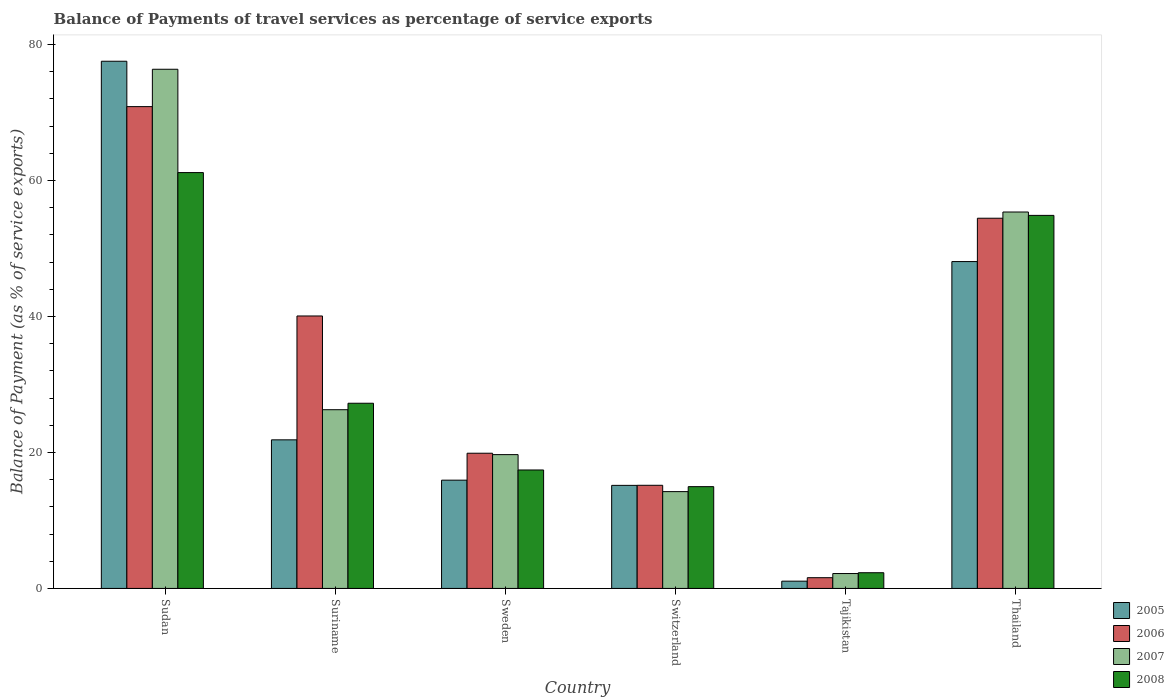Are the number of bars per tick equal to the number of legend labels?
Offer a very short reply. Yes. How many bars are there on the 1st tick from the left?
Your answer should be very brief. 4. What is the label of the 2nd group of bars from the left?
Offer a terse response. Suriname. What is the balance of payments of travel services in 2005 in Thailand?
Offer a very short reply. 48.07. Across all countries, what is the maximum balance of payments of travel services in 2006?
Offer a terse response. 70.85. Across all countries, what is the minimum balance of payments of travel services in 2007?
Provide a succinct answer. 2.19. In which country was the balance of payments of travel services in 2006 maximum?
Make the answer very short. Sudan. In which country was the balance of payments of travel services in 2006 minimum?
Your answer should be compact. Tajikistan. What is the total balance of payments of travel services in 2007 in the graph?
Your answer should be very brief. 194.09. What is the difference between the balance of payments of travel services in 2007 in Switzerland and that in Tajikistan?
Offer a very short reply. 12.05. What is the difference between the balance of payments of travel services in 2006 in Thailand and the balance of payments of travel services in 2008 in Sweden?
Your answer should be very brief. 37.02. What is the average balance of payments of travel services in 2006 per country?
Give a very brief answer. 33.67. What is the difference between the balance of payments of travel services of/in 2008 and balance of payments of travel services of/in 2007 in Sweden?
Your answer should be very brief. -2.26. What is the ratio of the balance of payments of travel services in 2008 in Sudan to that in Switzerland?
Ensure brevity in your answer.  4.09. Is the balance of payments of travel services in 2008 in Sweden less than that in Thailand?
Make the answer very short. Yes. Is the difference between the balance of payments of travel services in 2008 in Sweden and Tajikistan greater than the difference between the balance of payments of travel services in 2007 in Sweden and Tajikistan?
Your answer should be very brief. No. What is the difference between the highest and the second highest balance of payments of travel services in 2006?
Provide a short and direct response. 14.37. What is the difference between the highest and the lowest balance of payments of travel services in 2007?
Make the answer very short. 74.16. In how many countries, is the balance of payments of travel services in 2005 greater than the average balance of payments of travel services in 2005 taken over all countries?
Your response must be concise. 2. Is it the case that in every country, the sum of the balance of payments of travel services in 2007 and balance of payments of travel services in 2005 is greater than the sum of balance of payments of travel services in 2008 and balance of payments of travel services in 2006?
Ensure brevity in your answer.  No. What does the 1st bar from the right in Tajikistan represents?
Provide a short and direct response. 2008. How many bars are there?
Ensure brevity in your answer.  24. How many countries are there in the graph?
Keep it short and to the point. 6. What is the difference between two consecutive major ticks on the Y-axis?
Your answer should be very brief. 20. Does the graph contain grids?
Offer a terse response. No. How many legend labels are there?
Your answer should be compact. 4. What is the title of the graph?
Your answer should be compact. Balance of Payments of travel services as percentage of service exports. Does "1999" appear as one of the legend labels in the graph?
Provide a succinct answer. No. What is the label or title of the X-axis?
Make the answer very short. Country. What is the label or title of the Y-axis?
Provide a short and direct response. Balance of Payment (as % of service exports). What is the Balance of Payment (as % of service exports) of 2005 in Sudan?
Your answer should be very brief. 77.53. What is the Balance of Payment (as % of service exports) in 2006 in Sudan?
Make the answer very short. 70.85. What is the Balance of Payment (as % of service exports) of 2007 in Sudan?
Your answer should be very brief. 76.35. What is the Balance of Payment (as % of service exports) of 2008 in Sudan?
Your answer should be very brief. 61.15. What is the Balance of Payment (as % of service exports) in 2005 in Suriname?
Ensure brevity in your answer.  21.85. What is the Balance of Payment (as % of service exports) of 2006 in Suriname?
Give a very brief answer. 40.07. What is the Balance of Payment (as % of service exports) in 2007 in Suriname?
Keep it short and to the point. 26.28. What is the Balance of Payment (as % of service exports) in 2008 in Suriname?
Provide a short and direct response. 27.23. What is the Balance of Payment (as % of service exports) of 2005 in Sweden?
Provide a short and direct response. 15.92. What is the Balance of Payment (as % of service exports) in 2006 in Sweden?
Keep it short and to the point. 19.88. What is the Balance of Payment (as % of service exports) in 2007 in Sweden?
Your answer should be very brief. 19.68. What is the Balance of Payment (as % of service exports) in 2008 in Sweden?
Your answer should be very brief. 17.42. What is the Balance of Payment (as % of service exports) of 2005 in Switzerland?
Provide a succinct answer. 15.16. What is the Balance of Payment (as % of service exports) in 2006 in Switzerland?
Offer a terse response. 15.17. What is the Balance of Payment (as % of service exports) in 2007 in Switzerland?
Ensure brevity in your answer.  14.24. What is the Balance of Payment (as % of service exports) of 2008 in Switzerland?
Offer a terse response. 14.97. What is the Balance of Payment (as % of service exports) in 2005 in Tajikistan?
Keep it short and to the point. 1.07. What is the Balance of Payment (as % of service exports) in 2006 in Tajikistan?
Keep it short and to the point. 1.58. What is the Balance of Payment (as % of service exports) of 2007 in Tajikistan?
Your response must be concise. 2.19. What is the Balance of Payment (as % of service exports) of 2008 in Tajikistan?
Ensure brevity in your answer.  2.31. What is the Balance of Payment (as % of service exports) in 2005 in Thailand?
Offer a terse response. 48.07. What is the Balance of Payment (as % of service exports) of 2006 in Thailand?
Provide a short and direct response. 54.44. What is the Balance of Payment (as % of service exports) in 2007 in Thailand?
Provide a short and direct response. 55.36. What is the Balance of Payment (as % of service exports) in 2008 in Thailand?
Offer a very short reply. 54.86. Across all countries, what is the maximum Balance of Payment (as % of service exports) in 2005?
Give a very brief answer. 77.53. Across all countries, what is the maximum Balance of Payment (as % of service exports) of 2006?
Your response must be concise. 70.85. Across all countries, what is the maximum Balance of Payment (as % of service exports) of 2007?
Ensure brevity in your answer.  76.35. Across all countries, what is the maximum Balance of Payment (as % of service exports) of 2008?
Keep it short and to the point. 61.15. Across all countries, what is the minimum Balance of Payment (as % of service exports) of 2005?
Provide a succinct answer. 1.07. Across all countries, what is the minimum Balance of Payment (as % of service exports) of 2006?
Provide a succinct answer. 1.58. Across all countries, what is the minimum Balance of Payment (as % of service exports) of 2007?
Your answer should be very brief. 2.19. Across all countries, what is the minimum Balance of Payment (as % of service exports) in 2008?
Offer a terse response. 2.31. What is the total Balance of Payment (as % of service exports) of 2005 in the graph?
Provide a short and direct response. 179.6. What is the total Balance of Payment (as % of service exports) in 2006 in the graph?
Make the answer very short. 201.99. What is the total Balance of Payment (as % of service exports) in 2007 in the graph?
Make the answer very short. 194.09. What is the total Balance of Payment (as % of service exports) of 2008 in the graph?
Give a very brief answer. 177.95. What is the difference between the Balance of Payment (as % of service exports) of 2005 in Sudan and that in Suriname?
Provide a short and direct response. 55.68. What is the difference between the Balance of Payment (as % of service exports) of 2006 in Sudan and that in Suriname?
Ensure brevity in your answer.  30.79. What is the difference between the Balance of Payment (as % of service exports) of 2007 in Sudan and that in Suriname?
Provide a succinct answer. 50.07. What is the difference between the Balance of Payment (as % of service exports) in 2008 in Sudan and that in Suriname?
Your answer should be very brief. 33.92. What is the difference between the Balance of Payment (as % of service exports) in 2005 in Sudan and that in Sweden?
Your answer should be very brief. 61.61. What is the difference between the Balance of Payment (as % of service exports) in 2006 in Sudan and that in Sweden?
Your response must be concise. 50.97. What is the difference between the Balance of Payment (as % of service exports) of 2007 in Sudan and that in Sweden?
Offer a terse response. 56.67. What is the difference between the Balance of Payment (as % of service exports) in 2008 in Sudan and that in Sweden?
Keep it short and to the point. 43.73. What is the difference between the Balance of Payment (as % of service exports) of 2005 in Sudan and that in Switzerland?
Offer a very short reply. 62.37. What is the difference between the Balance of Payment (as % of service exports) in 2006 in Sudan and that in Switzerland?
Offer a very short reply. 55.69. What is the difference between the Balance of Payment (as % of service exports) of 2007 in Sudan and that in Switzerland?
Ensure brevity in your answer.  62.11. What is the difference between the Balance of Payment (as % of service exports) in 2008 in Sudan and that in Switzerland?
Make the answer very short. 46.19. What is the difference between the Balance of Payment (as % of service exports) in 2005 in Sudan and that in Tajikistan?
Your answer should be compact. 76.46. What is the difference between the Balance of Payment (as % of service exports) in 2006 in Sudan and that in Tajikistan?
Provide a short and direct response. 69.28. What is the difference between the Balance of Payment (as % of service exports) in 2007 in Sudan and that in Tajikistan?
Your response must be concise. 74.16. What is the difference between the Balance of Payment (as % of service exports) of 2008 in Sudan and that in Tajikistan?
Your response must be concise. 58.84. What is the difference between the Balance of Payment (as % of service exports) of 2005 in Sudan and that in Thailand?
Ensure brevity in your answer.  29.46. What is the difference between the Balance of Payment (as % of service exports) of 2006 in Sudan and that in Thailand?
Provide a short and direct response. 16.41. What is the difference between the Balance of Payment (as % of service exports) in 2007 in Sudan and that in Thailand?
Your response must be concise. 20.99. What is the difference between the Balance of Payment (as % of service exports) of 2008 in Sudan and that in Thailand?
Provide a short and direct response. 6.29. What is the difference between the Balance of Payment (as % of service exports) of 2005 in Suriname and that in Sweden?
Your response must be concise. 5.93. What is the difference between the Balance of Payment (as % of service exports) in 2006 in Suriname and that in Sweden?
Give a very brief answer. 20.18. What is the difference between the Balance of Payment (as % of service exports) in 2007 in Suriname and that in Sweden?
Give a very brief answer. 6.6. What is the difference between the Balance of Payment (as % of service exports) of 2008 in Suriname and that in Sweden?
Offer a terse response. 9.81. What is the difference between the Balance of Payment (as % of service exports) in 2005 in Suriname and that in Switzerland?
Your answer should be very brief. 6.7. What is the difference between the Balance of Payment (as % of service exports) in 2006 in Suriname and that in Switzerland?
Provide a short and direct response. 24.9. What is the difference between the Balance of Payment (as % of service exports) of 2007 in Suriname and that in Switzerland?
Ensure brevity in your answer.  12.04. What is the difference between the Balance of Payment (as % of service exports) of 2008 in Suriname and that in Switzerland?
Make the answer very short. 12.27. What is the difference between the Balance of Payment (as % of service exports) of 2005 in Suriname and that in Tajikistan?
Give a very brief answer. 20.78. What is the difference between the Balance of Payment (as % of service exports) of 2006 in Suriname and that in Tajikistan?
Your answer should be very brief. 38.49. What is the difference between the Balance of Payment (as % of service exports) in 2007 in Suriname and that in Tajikistan?
Offer a very short reply. 24.09. What is the difference between the Balance of Payment (as % of service exports) in 2008 in Suriname and that in Tajikistan?
Your answer should be compact. 24.92. What is the difference between the Balance of Payment (as % of service exports) of 2005 in Suriname and that in Thailand?
Ensure brevity in your answer.  -26.22. What is the difference between the Balance of Payment (as % of service exports) of 2006 in Suriname and that in Thailand?
Ensure brevity in your answer.  -14.37. What is the difference between the Balance of Payment (as % of service exports) in 2007 in Suriname and that in Thailand?
Ensure brevity in your answer.  -29.07. What is the difference between the Balance of Payment (as % of service exports) in 2008 in Suriname and that in Thailand?
Your answer should be very brief. -27.63. What is the difference between the Balance of Payment (as % of service exports) in 2005 in Sweden and that in Switzerland?
Your response must be concise. 0.77. What is the difference between the Balance of Payment (as % of service exports) in 2006 in Sweden and that in Switzerland?
Offer a very short reply. 4.72. What is the difference between the Balance of Payment (as % of service exports) in 2007 in Sweden and that in Switzerland?
Make the answer very short. 5.44. What is the difference between the Balance of Payment (as % of service exports) of 2008 in Sweden and that in Switzerland?
Provide a short and direct response. 2.45. What is the difference between the Balance of Payment (as % of service exports) of 2005 in Sweden and that in Tajikistan?
Give a very brief answer. 14.85. What is the difference between the Balance of Payment (as % of service exports) in 2006 in Sweden and that in Tajikistan?
Offer a terse response. 18.3. What is the difference between the Balance of Payment (as % of service exports) in 2007 in Sweden and that in Tajikistan?
Offer a very short reply. 17.49. What is the difference between the Balance of Payment (as % of service exports) in 2008 in Sweden and that in Tajikistan?
Your answer should be very brief. 15.11. What is the difference between the Balance of Payment (as % of service exports) in 2005 in Sweden and that in Thailand?
Your answer should be very brief. -32.15. What is the difference between the Balance of Payment (as % of service exports) of 2006 in Sweden and that in Thailand?
Provide a succinct answer. -34.56. What is the difference between the Balance of Payment (as % of service exports) in 2007 in Sweden and that in Thailand?
Your answer should be very brief. -35.68. What is the difference between the Balance of Payment (as % of service exports) of 2008 in Sweden and that in Thailand?
Your answer should be very brief. -37.44. What is the difference between the Balance of Payment (as % of service exports) of 2005 in Switzerland and that in Tajikistan?
Provide a succinct answer. 14.09. What is the difference between the Balance of Payment (as % of service exports) in 2006 in Switzerland and that in Tajikistan?
Ensure brevity in your answer.  13.59. What is the difference between the Balance of Payment (as % of service exports) in 2007 in Switzerland and that in Tajikistan?
Your response must be concise. 12.05. What is the difference between the Balance of Payment (as % of service exports) in 2008 in Switzerland and that in Tajikistan?
Ensure brevity in your answer.  12.66. What is the difference between the Balance of Payment (as % of service exports) in 2005 in Switzerland and that in Thailand?
Keep it short and to the point. -32.91. What is the difference between the Balance of Payment (as % of service exports) of 2006 in Switzerland and that in Thailand?
Give a very brief answer. -39.28. What is the difference between the Balance of Payment (as % of service exports) of 2007 in Switzerland and that in Thailand?
Make the answer very short. -41.12. What is the difference between the Balance of Payment (as % of service exports) in 2008 in Switzerland and that in Thailand?
Your response must be concise. -39.89. What is the difference between the Balance of Payment (as % of service exports) in 2005 in Tajikistan and that in Thailand?
Provide a short and direct response. -47. What is the difference between the Balance of Payment (as % of service exports) in 2006 in Tajikistan and that in Thailand?
Your answer should be compact. -52.86. What is the difference between the Balance of Payment (as % of service exports) of 2007 in Tajikistan and that in Thailand?
Offer a very short reply. -53.17. What is the difference between the Balance of Payment (as % of service exports) of 2008 in Tajikistan and that in Thailand?
Offer a terse response. -52.55. What is the difference between the Balance of Payment (as % of service exports) in 2005 in Sudan and the Balance of Payment (as % of service exports) in 2006 in Suriname?
Your answer should be very brief. 37.46. What is the difference between the Balance of Payment (as % of service exports) in 2005 in Sudan and the Balance of Payment (as % of service exports) in 2007 in Suriname?
Ensure brevity in your answer.  51.25. What is the difference between the Balance of Payment (as % of service exports) of 2005 in Sudan and the Balance of Payment (as % of service exports) of 2008 in Suriname?
Your answer should be compact. 50.29. What is the difference between the Balance of Payment (as % of service exports) of 2006 in Sudan and the Balance of Payment (as % of service exports) of 2007 in Suriname?
Provide a succinct answer. 44.57. What is the difference between the Balance of Payment (as % of service exports) of 2006 in Sudan and the Balance of Payment (as % of service exports) of 2008 in Suriname?
Provide a succinct answer. 43.62. What is the difference between the Balance of Payment (as % of service exports) in 2007 in Sudan and the Balance of Payment (as % of service exports) in 2008 in Suriname?
Your response must be concise. 49.12. What is the difference between the Balance of Payment (as % of service exports) of 2005 in Sudan and the Balance of Payment (as % of service exports) of 2006 in Sweden?
Give a very brief answer. 57.65. What is the difference between the Balance of Payment (as % of service exports) in 2005 in Sudan and the Balance of Payment (as % of service exports) in 2007 in Sweden?
Your answer should be compact. 57.85. What is the difference between the Balance of Payment (as % of service exports) of 2005 in Sudan and the Balance of Payment (as % of service exports) of 2008 in Sweden?
Provide a short and direct response. 60.11. What is the difference between the Balance of Payment (as % of service exports) of 2006 in Sudan and the Balance of Payment (as % of service exports) of 2007 in Sweden?
Offer a very short reply. 51.18. What is the difference between the Balance of Payment (as % of service exports) in 2006 in Sudan and the Balance of Payment (as % of service exports) in 2008 in Sweden?
Provide a succinct answer. 53.43. What is the difference between the Balance of Payment (as % of service exports) of 2007 in Sudan and the Balance of Payment (as % of service exports) of 2008 in Sweden?
Your answer should be compact. 58.93. What is the difference between the Balance of Payment (as % of service exports) in 2005 in Sudan and the Balance of Payment (as % of service exports) in 2006 in Switzerland?
Ensure brevity in your answer.  62.36. What is the difference between the Balance of Payment (as % of service exports) of 2005 in Sudan and the Balance of Payment (as % of service exports) of 2007 in Switzerland?
Offer a very short reply. 63.29. What is the difference between the Balance of Payment (as % of service exports) of 2005 in Sudan and the Balance of Payment (as % of service exports) of 2008 in Switzerland?
Offer a terse response. 62.56. What is the difference between the Balance of Payment (as % of service exports) in 2006 in Sudan and the Balance of Payment (as % of service exports) in 2007 in Switzerland?
Keep it short and to the point. 56.62. What is the difference between the Balance of Payment (as % of service exports) of 2006 in Sudan and the Balance of Payment (as % of service exports) of 2008 in Switzerland?
Provide a short and direct response. 55.89. What is the difference between the Balance of Payment (as % of service exports) in 2007 in Sudan and the Balance of Payment (as % of service exports) in 2008 in Switzerland?
Make the answer very short. 61.38. What is the difference between the Balance of Payment (as % of service exports) of 2005 in Sudan and the Balance of Payment (as % of service exports) of 2006 in Tajikistan?
Provide a succinct answer. 75.95. What is the difference between the Balance of Payment (as % of service exports) in 2005 in Sudan and the Balance of Payment (as % of service exports) in 2007 in Tajikistan?
Ensure brevity in your answer.  75.34. What is the difference between the Balance of Payment (as % of service exports) in 2005 in Sudan and the Balance of Payment (as % of service exports) in 2008 in Tajikistan?
Offer a very short reply. 75.22. What is the difference between the Balance of Payment (as % of service exports) in 2006 in Sudan and the Balance of Payment (as % of service exports) in 2007 in Tajikistan?
Make the answer very short. 68.66. What is the difference between the Balance of Payment (as % of service exports) of 2006 in Sudan and the Balance of Payment (as % of service exports) of 2008 in Tajikistan?
Offer a terse response. 68.54. What is the difference between the Balance of Payment (as % of service exports) in 2007 in Sudan and the Balance of Payment (as % of service exports) in 2008 in Tajikistan?
Offer a terse response. 74.04. What is the difference between the Balance of Payment (as % of service exports) of 2005 in Sudan and the Balance of Payment (as % of service exports) of 2006 in Thailand?
Offer a very short reply. 23.09. What is the difference between the Balance of Payment (as % of service exports) in 2005 in Sudan and the Balance of Payment (as % of service exports) in 2007 in Thailand?
Provide a short and direct response. 22.17. What is the difference between the Balance of Payment (as % of service exports) in 2005 in Sudan and the Balance of Payment (as % of service exports) in 2008 in Thailand?
Offer a very short reply. 22.67. What is the difference between the Balance of Payment (as % of service exports) of 2006 in Sudan and the Balance of Payment (as % of service exports) of 2007 in Thailand?
Ensure brevity in your answer.  15.5. What is the difference between the Balance of Payment (as % of service exports) of 2006 in Sudan and the Balance of Payment (as % of service exports) of 2008 in Thailand?
Provide a succinct answer. 15.99. What is the difference between the Balance of Payment (as % of service exports) of 2007 in Sudan and the Balance of Payment (as % of service exports) of 2008 in Thailand?
Your answer should be very brief. 21.49. What is the difference between the Balance of Payment (as % of service exports) in 2005 in Suriname and the Balance of Payment (as % of service exports) in 2006 in Sweden?
Your answer should be compact. 1.97. What is the difference between the Balance of Payment (as % of service exports) of 2005 in Suriname and the Balance of Payment (as % of service exports) of 2007 in Sweden?
Offer a terse response. 2.17. What is the difference between the Balance of Payment (as % of service exports) in 2005 in Suriname and the Balance of Payment (as % of service exports) in 2008 in Sweden?
Provide a short and direct response. 4.43. What is the difference between the Balance of Payment (as % of service exports) in 2006 in Suriname and the Balance of Payment (as % of service exports) in 2007 in Sweden?
Keep it short and to the point. 20.39. What is the difference between the Balance of Payment (as % of service exports) of 2006 in Suriname and the Balance of Payment (as % of service exports) of 2008 in Sweden?
Offer a very short reply. 22.65. What is the difference between the Balance of Payment (as % of service exports) in 2007 in Suriname and the Balance of Payment (as % of service exports) in 2008 in Sweden?
Make the answer very short. 8.86. What is the difference between the Balance of Payment (as % of service exports) in 2005 in Suriname and the Balance of Payment (as % of service exports) in 2006 in Switzerland?
Provide a succinct answer. 6.68. What is the difference between the Balance of Payment (as % of service exports) of 2005 in Suriname and the Balance of Payment (as % of service exports) of 2007 in Switzerland?
Keep it short and to the point. 7.61. What is the difference between the Balance of Payment (as % of service exports) in 2005 in Suriname and the Balance of Payment (as % of service exports) in 2008 in Switzerland?
Give a very brief answer. 6.88. What is the difference between the Balance of Payment (as % of service exports) of 2006 in Suriname and the Balance of Payment (as % of service exports) of 2007 in Switzerland?
Provide a succinct answer. 25.83. What is the difference between the Balance of Payment (as % of service exports) in 2006 in Suriname and the Balance of Payment (as % of service exports) in 2008 in Switzerland?
Give a very brief answer. 25.1. What is the difference between the Balance of Payment (as % of service exports) in 2007 in Suriname and the Balance of Payment (as % of service exports) in 2008 in Switzerland?
Offer a very short reply. 11.31. What is the difference between the Balance of Payment (as % of service exports) in 2005 in Suriname and the Balance of Payment (as % of service exports) in 2006 in Tajikistan?
Provide a short and direct response. 20.27. What is the difference between the Balance of Payment (as % of service exports) in 2005 in Suriname and the Balance of Payment (as % of service exports) in 2007 in Tajikistan?
Provide a succinct answer. 19.66. What is the difference between the Balance of Payment (as % of service exports) of 2005 in Suriname and the Balance of Payment (as % of service exports) of 2008 in Tajikistan?
Provide a short and direct response. 19.54. What is the difference between the Balance of Payment (as % of service exports) in 2006 in Suriname and the Balance of Payment (as % of service exports) in 2007 in Tajikistan?
Ensure brevity in your answer.  37.88. What is the difference between the Balance of Payment (as % of service exports) of 2006 in Suriname and the Balance of Payment (as % of service exports) of 2008 in Tajikistan?
Your answer should be compact. 37.76. What is the difference between the Balance of Payment (as % of service exports) of 2007 in Suriname and the Balance of Payment (as % of service exports) of 2008 in Tajikistan?
Provide a short and direct response. 23.97. What is the difference between the Balance of Payment (as % of service exports) in 2005 in Suriname and the Balance of Payment (as % of service exports) in 2006 in Thailand?
Your answer should be very brief. -32.59. What is the difference between the Balance of Payment (as % of service exports) of 2005 in Suriname and the Balance of Payment (as % of service exports) of 2007 in Thailand?
Provide a succinct answer. -33.5. What is the difference between the Balance of Payment (as % of service exports) of 2005 in Suriname and the Balance of Payment (as % of service exports) of 2008 in Thailand?
Make the answer very short. -33.01. What is the difference between the Balance of Payment (as % of service exports) of 2006 in Suriname and the Balance of Payment (as % of service exports) of 2007 in Thailand?
Provide a short and direct response. -15.29. What is the difference between the Balance of Payment (as % of service exports) in 2006 in Suriname and the Balance of Payment (as % of service exports) in 2008 in Thailand?
Make the answer very short. -14.79. What is the difference between the Balance of Payment (as % of service exports) in 2007 in Suriname and the Balance of Payment (as % of service exports) in 2008 in Thailand?
Ensure brevity in your answer.  -28.58. What is the difference between the Balance of Payment (as % of service exports) of 2005 in Sweden and the Balance of Payment (as % of service exports) of 2006 in Switzerland?
Provide a succinct answer. 0.76. What is the difference between the Balance of Payment (as % of service exports) in 2005 in Sweden and the Balance of Payment (as % of service exports) in 2007 in Switzerland?
Your answer should be very brief. 1.69. What is the difference between the Balance of Payment (as % of service exports) in 2005 in Sweden and the Balance of Payment (as % of service exports) in 2008 in Switzerland?
Ensure brevity in your answer.  0.96. What is the difference between the Balance of Payment (as % of service exports) of 2006 in Sweden and the Balance of Payment (as % of service exports) of 2007 in Switzerland?
Ensure brevity in your answer.  5.65. What is the difference between the Balance of Payment (as % of service exports) in 2006 in Sweden and the Balance of Payment (as % of service exports) in 2008 in Switzerland?
Your answer should be very brief. 4.92. What is the difference between the Balance of Payment (as % of service exports) in 2007 in Sweden and the Balance of Payment (as % of service exports) in 2008 in Switzerland?
Offer a very short reply. 4.71. What is the difference between the Balance of Payment (as % of service exports) in 2005 in Sweden and the Balance of Payment (as % of service exports) in 2006 in Tajikistan?
Offer a very short reply. 14.34. What is the difference between the Balance of Payment (as % of service exports) of 2005 in Sweden and the Balance of Payment (as % of service exports) of 2007 in Tajikistan?
Your response must be concise. 13.73. What is the difference between the Balance of Payment (as % of service exports) in 2005 in Sweden and the Balance of Payment (as % of service exports) in 2008 in Tajikistan?
Provide a succinct answer. 13.61. What is the difference between the Balance of Payment (as % of service exports) in 2006 in Sweden and the Balance of Payment (as % of service exports) in 2007 in Tajikistan?
Offer a very short reply. 17.69. What is the difference between the Balance of Payment (as % of service exports) of 2006 in Sweden and the Balance of Payment (as % of service exports) of 2008 in Tajikistan?
Give a very brief answer. 17.57. What is the difference between the Balance of Payment (as % of service exports) in 2007 in Sweden and the Balance of Payment (as % of service exports) in 2008 in Tajikistan?
Your response must be concise. 17.37. What is the difference between the Balance of Payment (as % of service exports) in 2005 in Sweden and the Balance of Payment (as % of service exports) in 2006 in Thailand?
Your answer should be compact. -38.52. What is the difference between the Balance of Payment (as % of service exports) of 2005 in Sweden and the Balance of Payment (as % of service exports) of 2007 in Thailand?
Offer a very short reply. -39.43. What is the difference between the Balance of Payment (as % of service exports) of 2005 in Sweden and the Balance of Payment (as % of service exports) of 2008 in Thailand?
Provide a short and direct response. -38.94. What is the difference between the Balance of Payment (as % of service exports) of 2006 in Sweden and the Balance of Payment (as % of service exports) of 2007 in Thailand?
Keep it short and to the point. -35.47. What is the difference between the Balance of Payment (as % of service exports) of 2006 in Sweden and the Balance of Payment (as % of service exports) of 2008 in Thailand?
Provide a short and direct response. -34.98. What is the difference between the Balance of Payment (as % of service exports) of 2007 in Sweden and the Balance of Payment (as % of service exports) of 2008 in Thailand?
Give a very brief answer. -35.18. What is the difference between the Balance of Payment (as % of service exports) of 2005 in Switzerland and the Balance of Payment (as % of service exports) of 2006 in Tajikistan?
Ensure brevity in your answer.  13.58. What is the difference between the Balance of Payment (as % of service exports) in 2005 in Switzerland and the Balance of Payment (as % of service exports) in 2007 in Tajikistan?
Give a very brief answer. 12.97. What is the difference between the Balance of Payment (as % of service exports) in 2005 in Switzerland and the Balance of Payment (as % of service exports) in 2008 in Tajikistan?
Your answer should be very brief. 12.85. What is the difference between the Balance of Payment (as % of service exports) of 2006 in Switzerland and the Balance of Payment (as % of service exports) of 2007 in Tajikistan?
Offer a very short reply. 12.98. What is the difference between the Balance of Payment (as % of service exports) of 2006 in Switzerland and the Balance of Payment (as % of service exports) of 2008 in Tajikistan?
Your response must be concise. 12.86. What is the difference between the Balance of Payment (as % of service exports) in 2007 in Switzerland and the Balance of Payment (as % of service exports) in 2008 in Tajikistan?
Offer a very short reply. 11.93. What is the difference between the Balance of Payment (as % of service exports) of 2005 in Switzerland and the Balance of Payment (as % of service exports) of 2006 in Thailand?
Make the answer very short. -39.29. What is the difference between the Balance of Payment (as % of service exports) in 2005 in Switzerland and the Balance of Payment (as % of service exports) in 2007 in Thailand?
Make the answer very short. -40.2. What is the difference between the Balance of Payment (as % of service exports) of 2005 in Switzerland and the Balance of Payment (as % of service exports) of 2008 in Thailand?
Ensure brevity in your answer.  -39.7. What is the difference between the Balance of Payment (as % of service exports) in 2006 in Switzerland and the Balance of Payment (as % of service exports) in 2007 in Thailand?
Offer a very short reply. -40.19. What is the difference between the Balance of Payment (as % of service exports) in 2006 in Switzerland and the Balance of Payment (as % of service exports) in 2008 in Thailand?
Give a very brief answer. -39.69. What is the difference between the Balance of Payment (as % of service exports) in 2007 in Switzerland and the Balance of Payment (as % of service exports) in 2008 in Thailand?
Give a very brief answer. -40.62. What is the difference between the Balance of Payment (as % of service exports) of 2005 in Tajikistan and the Balance of Payment (as % of service exports) of 2006 in Thailand?
Offer a very short reply. -53.37. What is the difference between the Balance of Payment (as % of service exports) of 2005 in Tajikistan and the Balance of Payment (as % of service exports) of 2007 in Thailand?
Provide a short and direct response. -54.29. What is the difference between the Balance of Payment (as % of service exports) of 2005 in Tajikistan and the Balance of Payment (as % of service exports) of 2008 in Thailand?
Keep it short and to the point. -53.79. What is the difference between the Balance of Payment (as % of service exports) of 2006 in Tajikistan and the Balance of Payment (as % of service exports) of 2007 in Thailand?
Keep it short and to the point. -53.78. What is the difference between the Balance of Payment (as % of service exports) of 2006 in Tajikistan and the Balance of Payment (as % of service exports) of 2008 in Thailand?
Offer a terse response. -53.28. What is the difference between the Balance of Payment (as % of service exports) of 2007 in Tajikistan and the Balance of Payment (as % of service exports) of 2008 in Thailand?
Give a very brief answer. -52.67. What is the average Balance of Payment (as % of service exports) in 2005 per country?
Keep it short and to the point. 29.93. What is the average Balance of Payment (as % of service exports) of 2006 per country?
Your response must be concise. 33.67. What is the average Balance of Payment (as % of service exports) of 2007 per country?
Your answer should be compact. 32.35. What is the average Balance of Payment (as % of service exports) of 2008 per country?
Offer a terse response. 29.66. What is the difference between the Balance of Payment (as % of service exports) in 2005 and Balance of Payment (as % of service exports) in 2006 in Sudan?
Offer a very short reply. 6.67. What is the difference between the Balance of Payment (as % of service exports) of 2005 and Balance of Payment (as % of service exports) of 2007 in Sudan?
Your answer should be compact. 1.18. What is the difference between the Balance of Payment (as % of service exports) in 2005 and Balance of Payment (as % of service exports) in 2008 in Sudan?
Provide a short and direct response. 16.38. What is the difference between the Balance of Payment (as % of service exports) of 2006 and Balance of Payment (as % of service exports) of 2007 in Sudan?
Provide a short and direct response. -5.5. What is the difference between the Balance of Payment (as % of service exports) of 2006 and Balance of Payment (as % of service exports) of 2008 in Sudan?
Provide a short and direct response. 9.7. What is the difference between the Balance of Payment (as % of service exports) of 2007 and Balance of Payment (as % of service exports) of 2008 in Sudan?
Provide a short and direct response. 15.2. What is the difference between the Balance of Payment (as % of service exports) of 2005 and Balance of Payment (as % of service exports) of 2006 in Suriname?
Your answer should be very brief. -18.22. What is the difference between the Balance of Payment (as % of service exports) of 2005 and Balance of Payment (as % of service exports) of 2007 in Suriname?
Your answer should be compact. -4.43. What is the difference between the Balance of Payment (as % of service exports) of 2005 and Balance of Payment (as % of service exports) of 2008 in Suriname?
Give a very brief answer. -5.38. What is the difference between the Balance of Payment (as % of service exports) in 2006 and Balance of Payment (as % of service exports) in 2007 in Suriname?
Offer a very short reply. 13.79. What is the difference between the Balance of Payment (as % of service exports) of 2006 and Balance of Payment (as % of service exports) of 2008 in Suriname?
Your response must be concise. 12.83. What is the difference between the Balance of Payment (as % of service exports) of 2007 and Balance of Payment (as % of service exports) of 2008 in Suriname?
Provide a short and direct response. -0.95. What is the difference between the Balance of Payment (as % of service exports) in 2005 and Balance of Payment (as % of service exports) in 2006 in Sweden?
Provide a succinct answer. -3.96. What is the difference between the Balance of Payment (as % of service exports) of 2005 and Balance of Payment (as % of service exports) of 2007 in Sweden?
Make the answer very short. -3.76. What is the difference between the Balance of Payment (as % of service exports) of 2005 and Balance of Payment (as % of service exports) of 2008 in Sweden?
Make the answer very short. -1.5. What is the difference between the Balance of Payment (as % of service exports) of 2006 and Balance of Payment (as % of service exports) of 2007 in Sweden?
Provide a short and direct response. 0.2. What is the difference between the Balance of Payment (as % of service exports) of 2006 and Balance of Payment (as % of service exports) of 2008 in Sweden?
Make the answer very short. 2.46. What is the difference between the Balance of Payment (as % of service exports) of 2007 and Balance of Payment (as % of service exports) of 2008 in Sweden?
Keep it short and to the point. 2.26. What is the difference between the Balance of Payment (as % of service exports) of 2005 and Balance of Payment (as % of service exports) of 2006 in Switzerland?
Your response must be concise. -0.01. What is the difference between the Balance of Payment (as % of service exports) of 2005 and Balance of Payment (as % of service exports) of 2007 in Switzerland?
Offer a terse response. 0.92. What is the difference between the Balance of Payment (as % of service exports) in 2005 and Balance of Payment (as % of service exports) in 2008 in Switzerland?
Offer a very short reply. 0.19. What is the difference between the Balance of Payment (as % of service exports) in 2006 and Balance of Payment (as % of service exports) in 2007 in Switzerland?
Your response must be concise. 0.93. What is the difference between the Balance of Payment (as % of service exports) in 2006 and Balance of Payment (as % of service exports) in 2008 in Switzerland?
Provide a short and direct response. 0.2. What is the difference between the Balance of Payment (as % of service exports) in 2007 and Balance of Payment (as % of service exports) in 2008 in Switzerland?
Provide a short and direct response. -0.73. What is the difference between the Balance of Payment (as % of service exports) of 2005 and Balance of Payment (as % of service exports) of 2006 in Tajikistan?
Give a very brief answer. -0.51. What is the difference between the Balance of Payment (as % of service exports) of 2005 and Balance of Payment (as % of service exports) of 2007 in Tajikistan?
Offer a terse response. -1.12. What is the difference between the Balance of Payment (as % of service exports) in 2005 and Balance of Payment (as % of service exports) in 2008 in Tajikistan?
Offer a terse response. -1.24. What is the difference between the Balance of Payment (as % of service exports) in 2006 and Balance of Payment (as % of service exports) in 2007 in Tajikistan?
Your answer should be compact. -0.61. What is the difference between the Balance of Payment (as % of service exports) in 2006 and Balance of Payment (as % of service exports) in 2008 in Tajikistan?
Provide a short and direct response. -0.73. What is the difference between the Balance of Payment (as % of service exports) in 2007 and Balance of Payment (as % of service exports) in 2008 in Tajikistan?
Give a very brief answer. -0.12. What is the difference between the Balance of Payment (as % of service exports) in 2005 and Balance of Payment (as % of service exports) in 2006 in Thailand?
Your answer should be very brief. -6.37. What is the difference between the Balance of Payment (as % of service exports) in 2005 and Balance of Payment (as % of service exports) in 2007 in Thailand?
Make the answer very short. -7.29. What is the difference between the Balance of Payment (as % of service exports) in 2005 and Balance of Payment (as % of service exports) in 2008 in Thailand?
Ensure brevity in your answer.  -6.79. What is the difference between the Balance of Payment (as % of service exports) of 2006 and Balance of Payment (as % of service exports) of 2007 in Thailand?
Provide a succinct answer. -0.91. What is the difference between the Balance of Payment (as % of service exports) of 2006 and Balance of Payment (as % of service exports) of 2008 in Thailand?
Provide a short and direct response. -0.42. What is the difference between the Balance of Payment (as % of service exports) of 2007 and Balance of Payment (as % of service exports) of 2008 in Thailand?
Your answer should be compact. 0.5. What is the ratio of the Balance of Payment (as % of service exports) in 2005 in Sudan to that in Suriname?
Offer a terse response. 3.55. What is the ratio of the Balance of Payment (as % of service exports) of 2006 in Sudan to that in Suriname?
Your response must be concise. 1.77. What is the ratio of the Balance of Payment (as % of service exports) of 2007 in Sudan to that in Suriname?
Offer a very short reply. 2.9. What is the ratio of the Balance of Payment (as % of service exports) in 2008 in Sudan to that in Suriname?
Your answer should be compact. 2.25. What is the ratio of the Balance of Payment (as % of service exports) in 2005 in Sudan to that in Sweden?
Keep it short and to the point. 4.87. What is the ratio of the Balance of Payment (as % of service exports) of 2006 in Sudan to that in Sweden?
Your answer should be very brief. 3.56. What is the ratio of the Balance of Payment (as % of service exports) of 2007 in Sudan to that in Sweden?
Your response must be concise. 3.88. What is the ratio of the Balance of Payment (as % of service exports) in 2008 in Sudan to that in Sweden?
Make the answer very short. 3.51. What is the ratio of the Balance of Payment (as % of service exports) of 2005 in Sudan to that in Switzerland?
Provide a short and direct response. 5.12. What is the ratio of the Balance of Payment (as % of service exports) in 2006 in Sudan to that in Switzerland?
Provide a succinct answer. 4.67. What is the ratio of the Balance of Payment (as % of service exports) of 2007 in Sudan to that in Switzerland?
Your answer should be compact. 5.36. What is the ratio of the Balance of Payment (as % of service exports) of 2008 in Sudan to that in Switzerland?
Give a very brief answer. 4.09. What is the ratio of the Balance of Payment (as % of service exports) of 2005 in Sudan to that in Tajikistan?
Your answer should be compact. 72.58. What is the ratio of the Balance of Payment (as % of service exports) of 2006 in Sudan to that in Tajikistan?
Offer a very short reply. 44.88. What is the ratio of the Balance of Payment (as % of service exports) in 2007 in Sudan to that in Tajikistan?
Provide a succinct answer. 34.87. What is the ratio of the Balance of Payment (as % of service exports) in 2008 in Sudan to that in Tajikistan?
Your answer should be compact. 26.47. What is the ratio of the Balance of Payment (as % of service exports) of 2005 in Sudan to that in Thailand?
Your response must be concise. 1.61. What is the ratio of the Balance of Payment (as % of service exports) in 2006 in Sudan to that in Thailand?
Provide a succinct answer. 1.3. What is the ratio of the Balance of Payment (as % of service exports) of 2007 in Sudan to that in Thailand?
Your answer should be very brief. 1.38. What is the ratio of the Balance of Payment (as % of service exports) in 2008 in Sudan to that in Thailand?
Offer a terse response. 1.11. What is the ratio of the Balance of Payment (as % of service exports) in 2005 in Suriname to that in Sweden?
Your response must be concise. 1.37. What is the ratio of the Balance of Payment (as % of service exports) in 2006 in Suriname to that in Sweden?
Offer a terse response. 2.02. What is the ratio of the Balance of Payment (as % of service exports) in 2007 in Suriname to that in Sweden?
Your answer should be very brief. 1.34. What is the ratio of the Balance of Payment (as % of service exports) in 2008 in Suriname to that in Sweden?
Your response must be concise. 1.56. What is the ratio of the Balance of Payment (as % of service exports) of 2005 in Suriname to that in Switzerland?
Your answer should be compact. 1.44. What is the ratio of the Balance of Payment (as % of service exports) in 2006 in Suriname to that in Switzerland?
Keep it short and to the point. 2.64. What is the ratio of the Balance of Payment (as % of service exports) in 2007 in Suriname to that in Switzerland?
Your answer should be compact. 1.85. What is the ratio of the Balance of Payment (as % of service exports) of 2008 in Suriname to that in Switzerland?
Offer a terse response. 1.82. What is the ratio of the Balance of Payment (as % of service exports) of 2005 in Suriname to that in Tajikistan?
Your response must be concise. 20.46. What is the ratio of the Balance of Payment (as % of service exports) in 2006 in Suriname to that in Tajikistan?
Provide a succinct answer. 25.38. What is the ratio of the Balance of Payment (as % of service exports) of 2007 in Suriname to that in Tajikistan?
Your answer should be compact. 12. What is the ratio of the Balance of Payment (as % of service exports) of 2008 in Suriname to that in Tajikistan?
Offer a terse response. 11.79. What is the ratio of the Balance of Payment (as % of service exports) of 2005 in Suriname to that in Thailand?
Your response must be concise. 0.45. What is the ratio of the Balance of Payment (as % of service exports) in 2006 in Suriname to that in Thailand?
Offer a very short reply. 0.74. What is the ratio of the Balance of Payment (as % of service exports) in 2007 in Suriname to that in Thailand?
Provide a succinct answer. 0.47. What is the ratio of the Balance of Payment (as % of service exports) in 2008 in Suriname to that in Thailand?
Provide a short and direct response. 0.5. What is the ratio of the Balance of Payment (as % of service exports) of 2005 in Sweden to that in Switzerland?
Offer a very short reply. 1.05. What is the ratio of the Balance of Payment (as % of service exports) of 2006 in Sweden to that in Switzerland?
Your response must be concise. 1.31. What is the ratio of the Balance of Payment (as % of service exports) of 2007 in Sweden to that in Switzerland?
Offer a terse response. 1.38. What is the ratio of the Balance of Payment (as % of service exports) in 2008 in Sweden to that in Switzerland?
Ensure brevity in your answer.  1.16. What is the ratio of the Balance of Payment (as % of service exports) of 2005 in Sweden to that in Tajikistan?
Your response must be concise. 14.91. What is the ratio of the Balance of Payment (as % of service exports) in 2006 in Sweden to that in Tajikistan?
Provide a short and direct response. 12.59. What is the ratio of the Balance of Payment (as % of service exports) of 2007 in Sweden to that in Tajikistan?
Ensure brevity in your answer.  8.99. What is the ratio of the Balance of Payment (as % of service exports) of 2008 in Sweden to that in Tajikistan?
Ensure brevity in your answer.  7.54. What is the ratio of the Balance of Payment (as % of service exports) in 2005 in Sweden to that in Thailand?
Offer a terse response. 0.33. What is the ratio of the Balance of Payment (as % of service exports) of 2006 in Sweden to that in Thailand?
Make the answer very short. 0.37. What is the ratio of the Balance of Payment (as % of service exports) in 2007 in Sweden to that in Thailand?
Your response must be concise. 0.36. What is the ratio of the Balance of Payment (as % of service exports) in 2008 in Sweden to that in Thailand?
Provide a succinct answer. 0.32. What is the ratio of the Balance of Payment (as % of service exports) in 2005 in Switzerland to that in Tajikistan?
Keep it short and to the point. 14.19. What is the ratio of the Balance of Payment (as % of service exports) in 2006 in Switzerland to that in Tajikistan?
Give a very brief answer. 9.61. What is the ratio of the Balance of Payment (as % of service exports) in 2007 in Switzerland to that in Tajikistan?
Keep it short and to the point. 6.5. What is the ratio of the Balance of Payment (as % of service exports) of 2008 in Switzerland to that in Tajikistan?
Provide a succinct answer. 6.48. What is the ratio of the Balance of Payment (as % of service exports) of 2005 in Switzerland to that in Thailand?
Your answer should be very brief. 0.32. What is the ratio of the Balance of Payment (as % of service exports) in 2006 in Switzerland to that in Thailand?
Your answer should be very brief. 0.28. What is the ratio of the Balance of Payment (as % of service exports) of 2007 in Switzerland to that in Thailand?
Provide a succinct answer. 0.26. What is the ratio of the Balance of Payment (as % of service exports) of 2008 in Switzerland to that in Thailand?
Your answer should be very brief. 0.27. What is the ratio of the Balance of Payment (as % of service exports) of 2005 in Tajikistan to that in Thailand?
Offer a terse response. 0.02. What is the ratio of the Balance of Payment (as % of service exports) of 2006 in Tajikistan to that in Thailand?
Your response must be concise. 0.03. What is the ratio of the Balance of Payment (as % of service exports) in 2007 in Tajikistan to that in Thailand?
Offer a very short reply. 0.04. What is the ratio of the Balance of Payment (as % of service exports) in 2008 in Tajikistan to that in Thailand?
Give a very brief answer. 0.04. What is the difference between the highest and the second highest Balance of Payment (as % of service exports) in 2005?
Keep it short and to the point. 29.46. What is the difference between the highest and the second highest Balance of Payment (as % of service exports) of 2006?
Make the answer very short. 16.41. What is the difference between the highest and the second highest Balance of Payment (as % of service exports) of 2007?
Ensure brevity in your answer.  20.99. What is the difference between the highest and the second highest Balance of Payment (as % of service exports) of 2008?
Give a very brief answer. 6.29. What is the difference between the highest and the lowest Balance of Payment (as % of service exports) in 2005?
Provide a short and direct response. 76.46. What is the difference between the highest and the lowest Balance of Payment (as % of service exports) in 2006?
Keep it short and to the point. 69.28. What is the difference between the highest and the lowest Balance of Payment (as % of service exports) of 2007?
Ensure brevity in your answer.  74.16. What is the difference between the highest and the lowest Balance of Payment (as % of service exports) in 2008?
Provide a succinct answer. 58.84. 